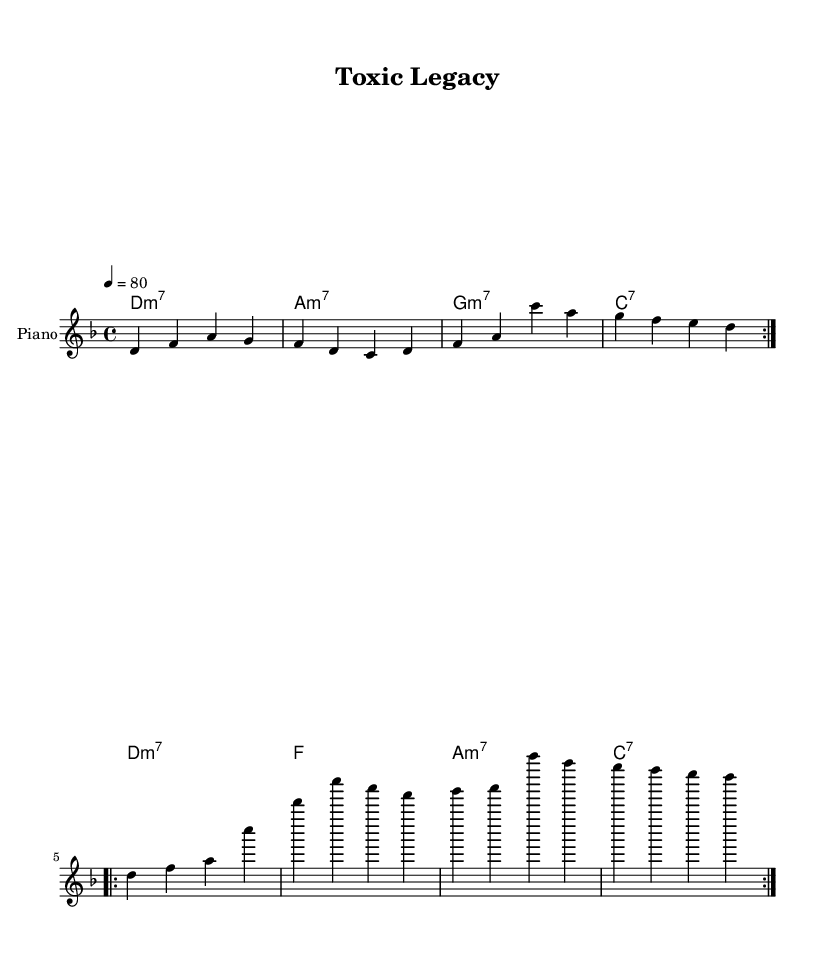What is the key signature of this music? The key signature has two flats, which indicates it is in D minor.
Answer: D minor What is the time signature of the piece? The time signature is displayed at the beginning of the score as 4/4, indicating four beats per measure.
Answer: 4/4 What is the tempo marking for this composition? The tempo is indicated in beats per minute as 80, specifying a moderate pace for the piece.
Answer: 80 How many measures are in the first section of the melody? The first section of the melody repeats twice, with each repetition containing four measures, totaling eight measures.
Answer: 8 What type of chords are primarily used in the piece? The chords include minor seventh and dominant seventh chords, indicating a jazz-influenced harmony typical in rhythm and blues.
Answer: Minor seventh and dominant seventh What is the structure of the melody in terms of repetitions? The melody consists of two sections that repeat twice each, creating a total of four repetitions across the piece.
Answer: Four repetitions Which instrument is notated in the sheet music? The score indicates a staff for the piano, suggesting that this music is specifically arranged for that instrument.
Answer: Piano 